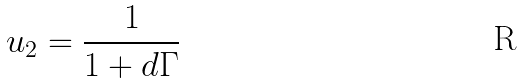Convert formula to latex. <formula><loc_0><loc_0><loc_500><loc_500>u _ { 2 } = \frac { 1 } { 1 + d \Gamma }</formula> 